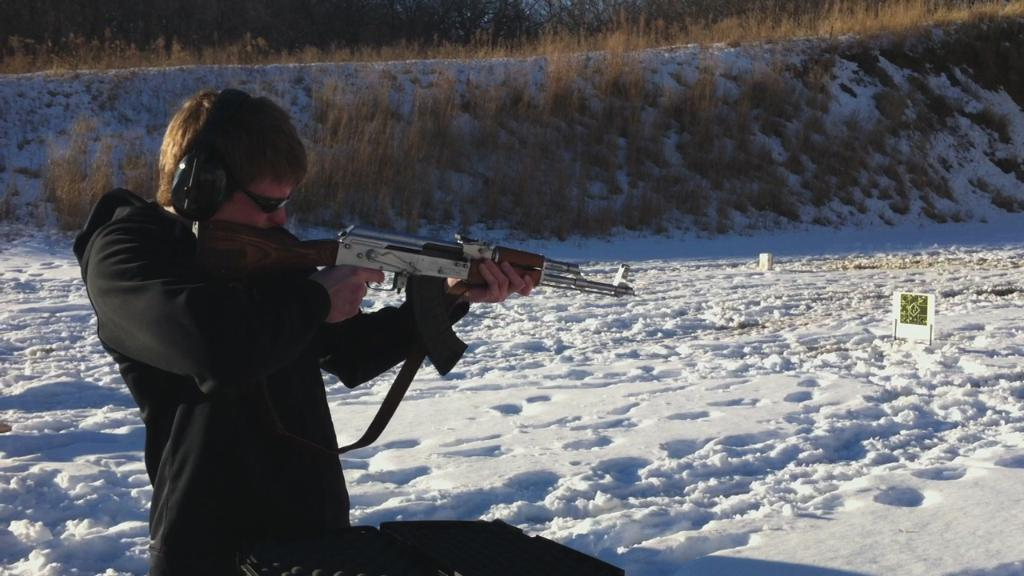Who is present in the image? There is a man in the image. What is the man wearing? The man is wearing a black dress. What is the man holding in the image? The man is holding a gun. What is the condition of the land in the image? The surface of the land is covered with snow. What type of vegetation can be seen in the background of the image? There are trees and grass in the background of the image. What type of learning is the rat doing with its thumb in the image? There is no rat or thumb present in the image. 